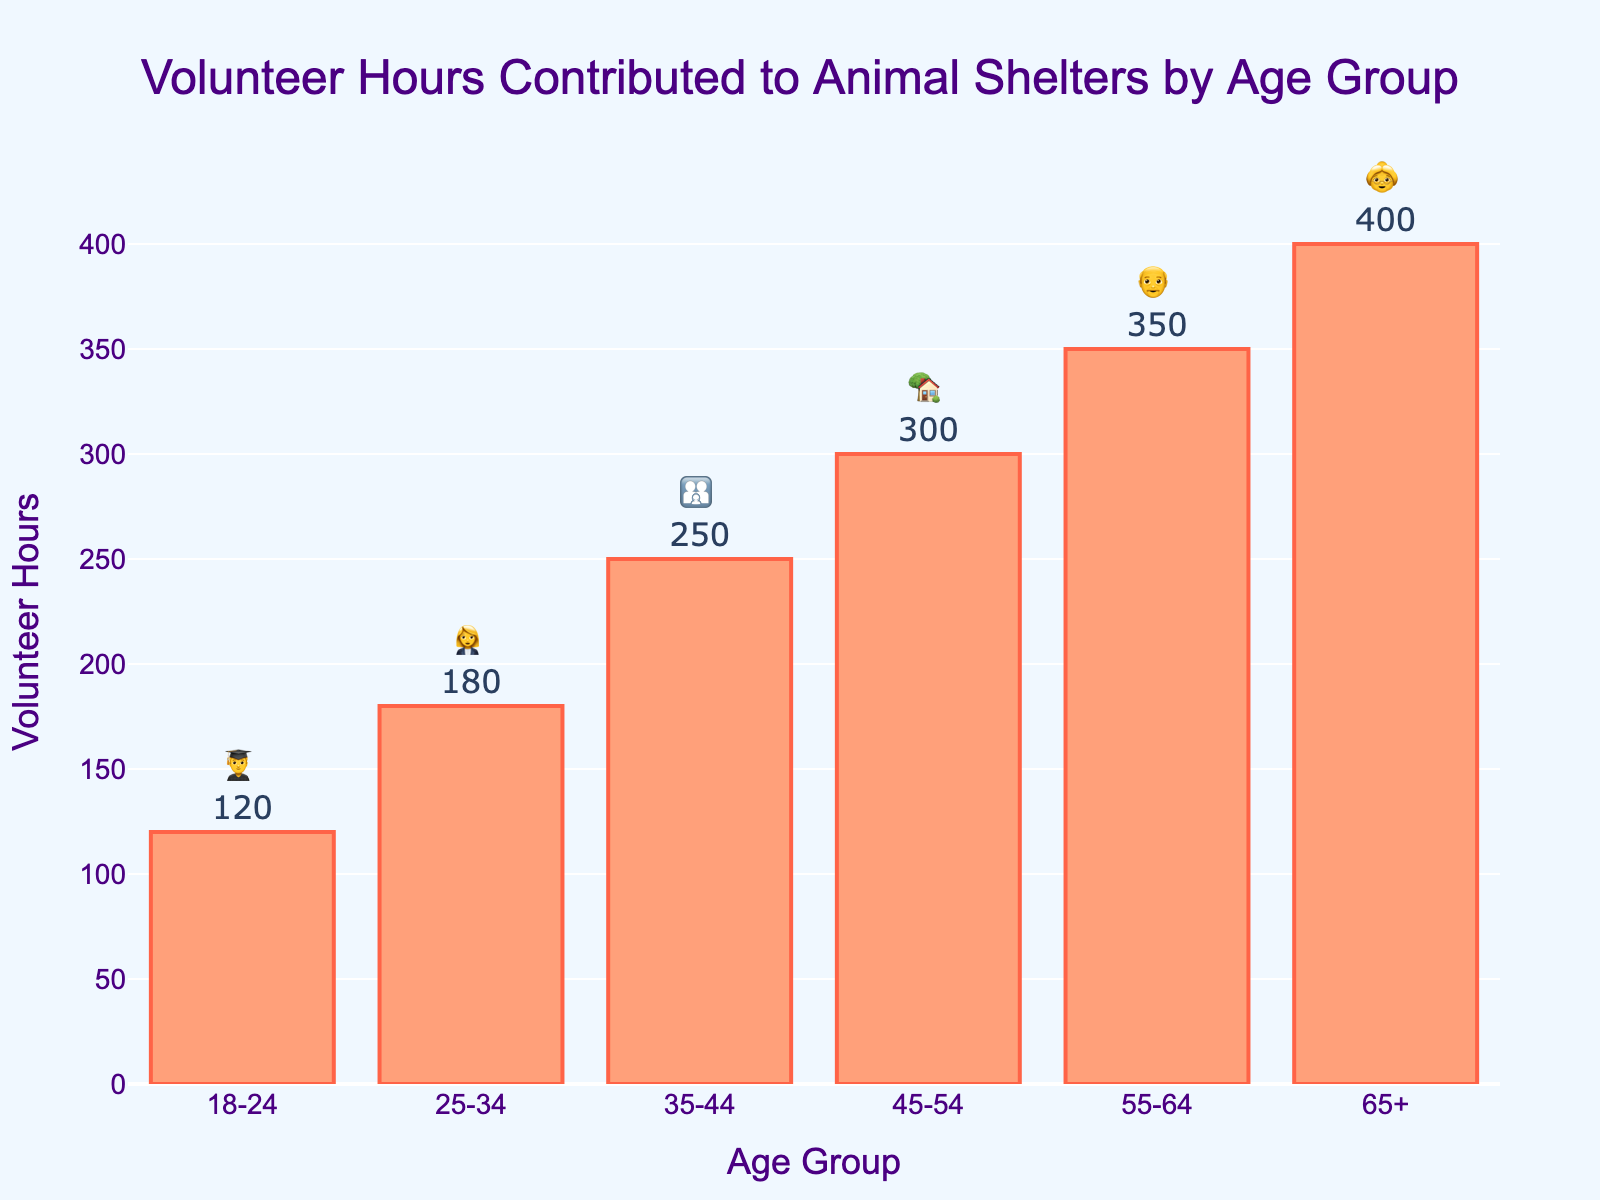What's the title of the chart? The title is located at the top of the chart and typically provides a descriptive overview of the chart's content. In this case, it reads "Volunteer Hours Contributed to Animal Shelters by Age Group."
Answer: Volunteer Hours Contributed to Animal Shelters by Age Group What age group contributed the highest number of volunteer hours? By examining the height of the bars or checking the values associated with each age group, the data shows that the 65+ age group contributed 400 volunteer hours, which is the highest.
Answer: 65+ What is the total number of volunteer hours contributed by all age groups combined? To find the total, sum the volunteer hours from each age group: 120 (18-24) + 180 (25-34) + 250 (35-44) + 300 (45-54) + 350 (55-64) + 400 (65+). The total is 1600.
Answer: 1600 Which age group contributed fewer hours, 25-34 or 35-44? By comparing the heights of the bars and their values, it is evident that the 25-34 age group contributed 180 hours, while the 35-44 group contributed 250 hours. Therefore, the 25-34 age group contributed fewer hours.
Answer: 25-34 How much more did the 55-64 age group contribute compared to the 18-24 age group? Find the difference between the volunteer hours of the 55-64 age group and the 18-24 age group: 350 (55-64) - 120 (18-24). The difference is 230 hours.
Answer: 230 Which emoji represents the 45-54 age group? Each age group is associated with a specific emoji shown above the bar. The emoji for the 45-54 age group is the house emoji, 🏡.
Answer: 🏡 What is the average number of volunteer hours contributed per age group? To find the average, divide the total number of volunteer hours by the number of age groups. The total is 1600, and there are 6 age groups. The average volunteer hours are 1600 / 6 = 266.67 hours.
Answer: 266.67 Which two age groups combined contributed the same or closest to the 45-54 age group's total volunteer hours (300 hours)? Consider combinations of volunteer hours from other age groups to find the closest sum to 300 hours. The 18-24 group (120 hours) and the 25-34 group (180 hours) sum to 300 hours, which matches the 45-54 group.
Answer: 18-24 and 25-34 What is the difference between the total volunteer hours of the youngest (18-24) and the oldest (65+) age groups? Subtract the volunteer hours of the 18-24 age group from the 65+ age group: 400 (65+) - 120 (18-24). The difference is 280 hours.
Answer: 280 